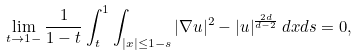<formula> <loc_0><loc_0><loc_500><loc_500>\lim _ { t \to 1 - } \frac { 1 } { 1 - t } \int _ { t } ^ { 1 } \int _ { | x | \leq 1 - s } | \nabla u | ^ { 2 } - | u | ^ { \frac { 2 d } { d - 2 } } \, d x d s = 0 ,</formula> 